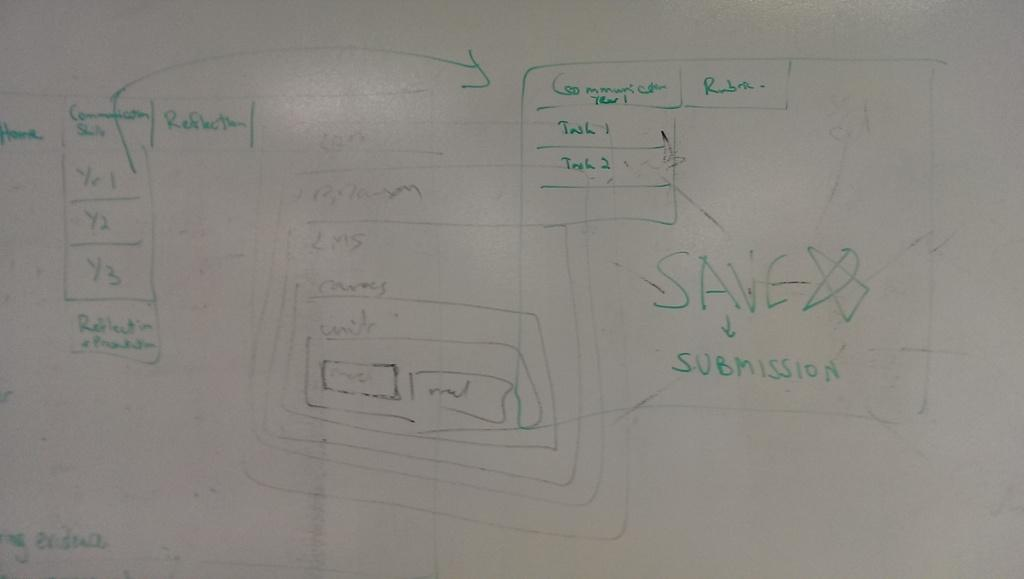<image>
Offer a succinct explanation of the picture presented. A diagram on a whiteboard says, 'save submission', on it. 